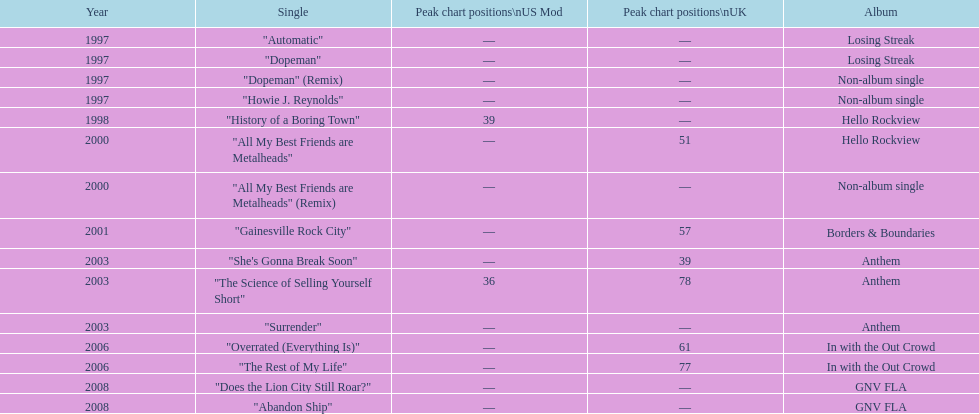Which single was the first to achieve a position on the charts? "History of a Boring Town". 